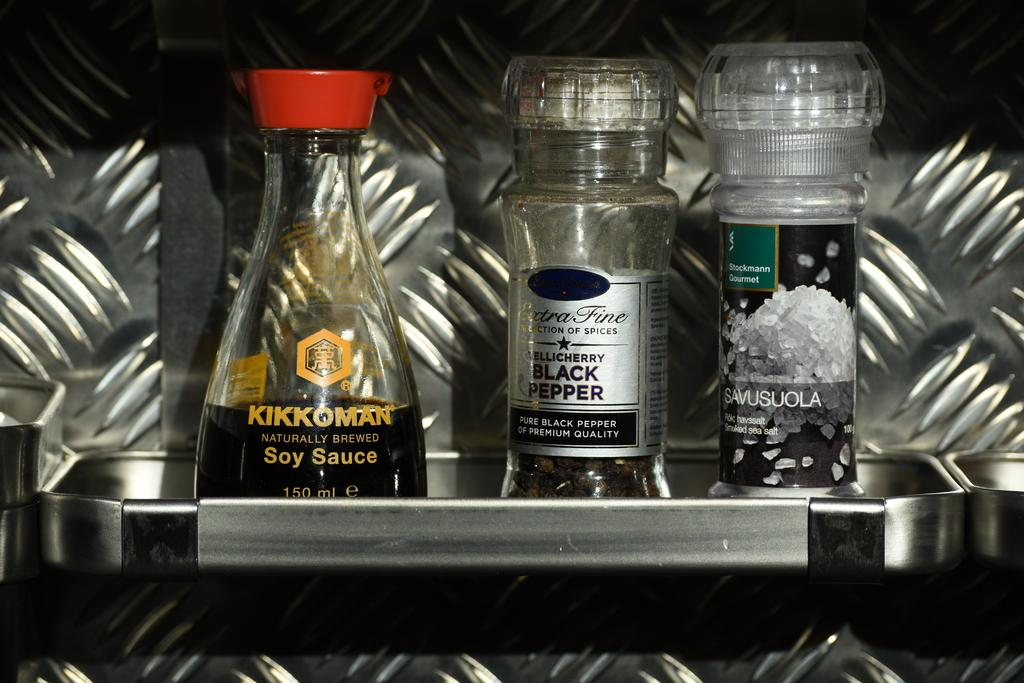<image>
Render a clear and concise summary of the photo. a trio of food enhancers, including KIKKOMAN Soy Sauce, Extra Fine Black Pepper and SAVUSUOLA smoked sea salt. 